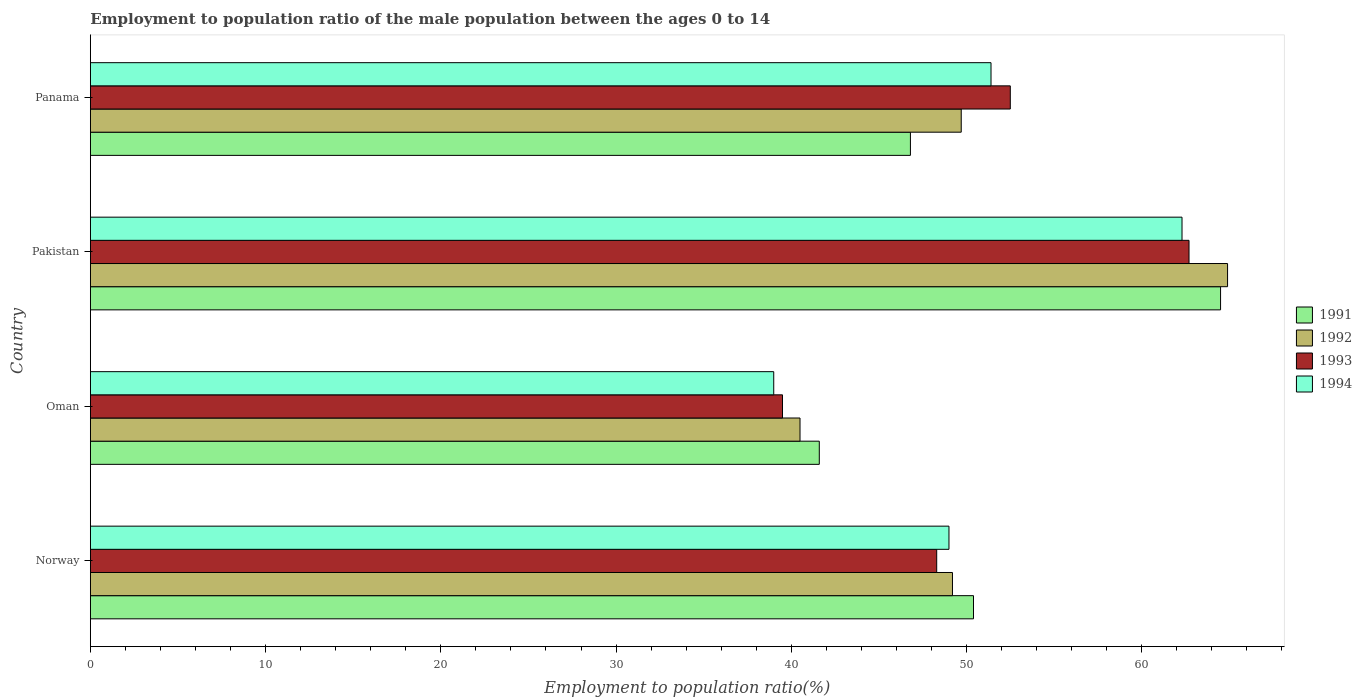How many different coloured bars are there?
Provide a short and direct response. 4. Are the number of bars per tick equal to the number of legend labels?
Provide a succinct answer. Yes. How many bars are there on the 3rd tick from the top?
Offer a terse response. 4. How many bars are there on the 1st tick from the bottom?
Provide a short and direct response. 4. What is the employment to population ratio in 1994 in Panama?
Provide a short and direct response. 51.4. Across all countries, what is the maximum employment to population ratio in 1992?
Your response must be concise. 64.9. Across all countries, what is the minimum employment to population ratio in 1994?
Your answer should be compact. 39. In which country was the employment to population ratio in 1994 minimum?
Ensure brevity in your answer.  Oman. What is the total employment to population ratio in 1991 in the graph?
Provide a short and direct response. 203.3. What is the difference between the employment to population ratio in 1992 in Oman and the employment to population ratio in 1993 in Pakistan?
Keep it short and to the point. -22.2. What is the average employment to population ratio in 1993 per country?
Keep it short and to the point. 50.75. What is the difference between the employment to population ratio in 1991 and employment to population ratio in 1993 in Pakistan?
Provide a short and direct response. 1.8. In how many countries, is the employment to population ratio in 1991 greater than 26 %?
Give a very brief answer. 4. What is the ratio of the employment to population ratio in 1992 in Pakistan to that in Panama?
Your response must be concise. 1.31. Is the employment to population ratio in 1993 in Norway less than that in Panama?
Offer a very short reply. Yes. Is the difference between the employment to population ratio in 1991 in Pakistan and Panama greater than the difference between the employment to population ratio in 1993 in Pakistan and Panama?
Ensure brevity in your answer.  Yes. What is the difference between the highest and the second highest employment to population ratio in 1991?
Provide a succinct answer. 14.1. What is the difference between the highest and the lowest employment to population ratio in 1994?
Ensure brevity in your answer.  23.3. Is it the case that in every country, the sum of the employment to population ratio in 1993 and employment to population ratio in 1991 is greater than the sum of employment to population ratio in 1992 and employment to population ratio in 1994?
Provide a short and direct response. No. What does the 4th bar from the bottom in Panama represents?
Give a very brief answer. 1994. Is it the case that in every country, the sum of the employment to population ratio in 1993 and employment to population ratio in 1992 is greater than the employment to population ratio in 1994?
Ensure brevity in your answer.  Yes. How many countries are there in the graph?
Provide a short and direct response. 4. What is the difference between two consecutive major ticks on the X-axis?
Your answer should be compact. 10. Does the graph contain any zero values?
Your response must be concise. No. Does the graph contain grids?
Ensure brevity in your answer.  No. How many legend labels are there?
Provide a short and direct response. 4. How are the legend labels stacked?
Offer a terse response. Vertical. What is the title of the graph?
Your answer should be very brief. Employment to population ratio of the male population between the ages 0 to 14. Does "1993" appear as one of the legend labels in the graph?
Offer a terse response. Yes. What is the label or title of the Y-axis?
Keep it short and to the point. Country. What is the Employment to population ratio(%) in 1991 in Norway?
Provide a short and direct response. 50.4. What is the Employment to population ratio(%) in 1992 in Norway?
Your response must be concise. 49.2. What is the Employment to population ratio(%) in 1993 in Norway?
Give a very brief answer. 48.3. What is the Employment to population ratio(%) of 1991 in Oman?
Provide a succinct answer. 41.6. What is the Employment to population ratio(%) in 1992 in Oman?
Your answer should be compact. 40.5. What is the Employment to population ratio(%) of 1993 in Oman?
Provide a short and direct response. 39.5. What is the Employment to population ratio(%) of 1994 in Oman?
Ensure brevity in your answer.  39. What is the Employment to population ratio(%) in 1991 in Pakistan?
Offer a very short reply. 64.5. What is the Employment to population ratio(%) of 1992 in Pakistan?
Keep it short and to the point. 64.9. What is the Employment to population ratio(%) in 1993 in Pakistan?
Ensure brevity in your answer.  62.7. What is the Employment to population ratio(%) in 1994 in Pakistan?
Your answer should be very brief. 62.3. What is the Employment to population ratio(%) in 1991 in Panama?
Offer a very short reply. 46.8. What is the Employment to population ratio(%) of 1992 in Panama?
Give a very brief answer. 49.7. What is the Employment to population ratio(%) in 1993 in Panama?
Give a very brief answer. 52.5. What is the Employment to population ratio(%) in 1994 in Panama?
Your response must be concise. 51.4. Across all countries, what is the maximum Employment to population ratio(%) of 1991?
Make the answer very short. 64.5. Across all countries, what is the maximum Employment to population ratio(%) in 1992?
Provide a succinct answer. 64.9. Across all countries, what is the maximum Employment to population ratio(%) in 1993?
Provide a short and direct response. 62.7. Across all countries, what is the maximum Employment to population ratio(%) of 1994?
Provide a succinct answer. 62.3. Across all countries, what is the minimum Employment to population ratio(%) in 1991?
Give a very brief answer. 41.6. Across all countries, what is the minimum Employment to population ratio(%) in 1992?
Keep it short and to the point. 40.5. Across all countries, what is the minimum Employment to population ratio(%) of 1993?
Offer a terse response. 39.5. What is the total Employment to population ratio(%) of 1991 in the graph?
Give a very brief answer. 203.3. What is the total Employment to population ratio(%) in 1992 in the graph?
Offer a very short reply. 204.3. What is the total Employment to population ratio(%) in 1993 in the graph?
Your answer should be compact. 203. What is the total Employment to population ratio(%) of 1994 in the graph?
Make the answer very short. 201.7. What is the difference between the Employment to population ratio(%) in 1991 in Norway and that in Oman?
Your response must be concise. 8.8. What is the difference between the Employment to population ratio(%) in 1992 in Norway and that in Oman?
Provide a succinct answer. 8.7. What is the difference between the Employment to population ratio(%) in 1991 in Norway and that in Pakistan?
Ensure brevity in your answer.  -14.1. What is the difference between the Employment to population ratio(%) of 1992 in Norway and that in Pakistan?
Provide a short and direct response. -15.7. What is the difference between the Employment to population ratio(%) in 1993 in Norway and that in Pakistan?
Keep it short and to the point. -14.4. What is the difference between the Employment to population ratio(%) in 1994 in Norway and that in Pakistan?
Keep it short and to the point. -13.3. What is the difference between the Employment to population ratio(%) of 1991 in Norway and that in Panama?
Offer a very short reply. 3.6. What is the difference between the Employment to population ratio(%) in 1992 in Norway and that in Panama?
Your response must be concise. -0.5. What is the difference between the Employment to population ratio(%) of 1993 in Norway and that in Panama?
Keep it short and to the point. -4.2. What is the difference between the Employment to population ratio(%) in 1991 in Oman and that in Pakistan?
Your answer should be compact. -22.9. What is the difference between the Employment to population ratio(%) of 1992 in Oman and that in Pakistan?
Give a very brief answer. -24.4. What is the difference between the Employment to population ratio(%) in 1993 in Oman and that in Pakistan?
Ensure brevity in your answer.  -23.2. What is the difference between the Employment to population ratio(%) in 1994 in Oman and that in Pakistan?
Keep it short and to the point. -23.3. What is the difference between the Employment to population ratio(%) of 1993 in Oman and that in Panama?
Your response must be concise. -13. What is the difference between the Employment to population ratio(%) of 1994 in Oman and that in Panama?
Your response must be concise. -12.4. What is the difference between the Employment to population ratio(%) in 1991 in Pakistan and that in Panama?
Offer a very short reply. 17.7. What is the difference between the Employment to population ratio(%) of 1992 in Pakistan and that in Panama?
Provide a succinct answer. 15.2. What is the difference between the Employment to population ratio(%) of 1993 in Pakistan and that in Panama?
Give a very brief answer. 10.2. What is the difference between the Employment to population ratio(%) in 1992 in Norway and the Employment to population ratio(%) in 1993 in Oman?
Offer a very short reply. 9.7. What is the difference between the Employment to population ratio(%) in 1993 in Norway and the Employment to population ratio(%) in 1994 in Oman?
Provide a succinct answer. 9.3. What is the difference between the Employment to population ratio(%) in 1991 in Norway and the Employment to population ratio(%) in 1992 in Pakistan?
Provide a short and direct response. -14.5. What is the difference between the Employment to population ratio(%) of 1991 in Norway and the Employment to population ratio(%) of 1993 in Pakistan?
Provide a short and direct response. -12.3. What is the difference between the Employment to population ratio(%) in 1991 in Norway and the Employment to population ratio(%) in 1994 in Pakistan?
Provide a short and direct response. -11.9. What is the difference between the Employment to population ratio(%) of 1993 in Norway and the Employment to population ratio(%) of 1994 in Pakistan?
Your answer should be compact. -14. What is the difference between the Employment to population ratio(%) of 1992 in Norway and the Employment to population ratio(%) of 1994 in Panama?
Offer a terse response. -2.2. What is the difference between the Employment to population ratio(%) in 1993 in Norway and the Employment to population ratio(%) in 1994 in Panama?
Your answer should be very brief. -3.1. What is the difference between the Employment to population ratio(%) in 1991 in Oman and the Employment to population ratio(%) in 1992 in Pakistan?
Your answer should be very brief. -23.3. What is the difference between the Employment to population ratio(%) in 1991 in Oman and the Employment to population ratio(%) in 1993 in Pakistan?
Keep it short and to the point. -21.1. What is the difference between the Employment to population ratio(%) of 1991 in Oman and the Employment to population ratio(%) of 1994 in Pakistan?
Offer a terse response. -20.7. What is the difference between the Employment to population ratio(%) of 1992 in Oman and the Employment to population ratio(%) of 1993 in Pakistan?
Your response must be concise. -22.2. What is the difference between the Employment to population ratio(%) of 1992 in Oman and the Employment to population ratio(%) of 1994 in Pakistan?
Make the answer very short. -21.8. What is the difference between the Employment to population ratio(%) in 1993 in Oman and the Employment to population ratio(%) in 1994 in Pakistan?
Offer a very short reply. -22.8. What is the difference between the Employment to population ratio(%) in 1991 in Oman and the Employment to population ratio(%) in 1993 in Panama?
Your answer should be compact. -10.9. What is the difference between the Employment to population ratio(%) of 1991 in Oman and the Employment to population ratio(%) of 1994 in Panama?
Offer a terse response. -9.8. What is the difference between the Employment to population ratio(%) in 1992 in Oman and the Employment to population ratio(%) in 1994 in Panama?
Ensure brevity in your answer.  -10.9. What is the difference between the Employment to population ratio(%) in 1993 in Pakistan and the Employment to population ratio(%) in 1994 in Panama?
Offer a very short reply. 11.3. What is the average Employment to population ratio(%) of 1991 per country?
Ensure brevity in your answer.  50.83. What is the average Employment to population ratio(%) of 1992 per country?
Make the answer very short. 51.08. What is the average Employment to population ratio(%) in 1993 per country?
Offer a terse response. 50.75. What is the average Employment to population ratio(%) in 1994 per country?
Give a very brief answer. 50.42. What is the difference between the Employment to population ratio(%) in 1992 and Employment to population ratio(%) in 1993 in Norway?
Keep it short and to the point. 0.9. What is the difference between the Employment to population ratio(%) of 1992 and Employment to population ratio(%) of 1994 in Norway?
Your response must be concise. 0.2. What is the difference between the Employment to population ratio(%) in 1993 and Employment to population ratio(%) in 1994 in Norway?
Make the answer very short. -0.7. What is the difference between the Employment to population ratio(%) in 1991 and Employment to population ratio(%) in 1992 in Oman?
Ensure brevity in your answer.  1.1. What is the difference between the Employment to population ratio(%) of 1991 and Employment to population ratio(%) of 1993 in Oman?
Offer a very short reply. 2.1. What is the difference between the Employment to population ratio(%) of 1991 and Employment to population ratio(%) of 1994 in Oman?
Offer a terse response. 2.6. What is the difference between the Employment to population ratio(%) in 1991 and Employment to population ratio(%) in 1993 in Pakistan?
Offer a very short reply. 1.8. What is the difference between the Employment to population ratio(%) in 1992 and Employment to population ratio(%) in 1993 in Pakistan?
Provide a short and direct response. 2.2. What is the difference between the Employment to population ratio(%) of 1991 and Employment to population ratio(%) of 1992 in Panama?
Keep it short and to the point. -2.9. What is the difference between the Employment to population ratio(%) in 1991 and Employment to population ratio(%) in 1993 in Panama?
Provide a short and direct response. -5.7. What is the difference between the Employment to population ratio(%) of 1993 and Employment to population ratio(%) of 1994 in Panama?
Give a very brief answer. 1.1. What is the ratio of the Employment to population ratio(%) of 1991 in Norway to that in Oman?
Keep it short and to the point. 1.21. What is the ratio of the Employment to population ratio(%) in 1992 in Norway to that in Oman?
Keep it short and to the point. 1.21. What is the ratio of the Employment to population ratio(%) in 1993 in Norway to that in Oman?
Your response must be concise. 1.22. What is the ratio of the Employment to population ratio(%) in 1994 in Norway to that in Oman?
Keep it short and to the point. 1.26. What is the ratio of the Employment to population ratio(%) in 1991 in Norway to that in Pakistan?
Provide a short and direct response. 0.78. What is the ratio of the Employment to population ratio(%) in 1992 in Norway to that in Pakistan?
Your answer should be compact. 0.76. What is the ratio of the Employment to population ratio(%) in 1993 in Norway to that in Pakistan?
Keep it short and to the point. 0.77. What is the ratio of the Employment to population ratio(%) of 1994 in Norway to that in Pakistan?
Make the answer very short. 0.79. What is the ratio of the Employment to population ratio(%) of 1994 in Norway to that in Panama?
Your response must be concise. 0.95. What is the ratio of the Employment to population ratio(%) in 1991 in Oman to that in Pakistan?
Offer a terse response. 0.65. What is the ratio of the Employment to population ratio(%) of 1992 in Oman to that in Pakistan?
Make the answer very short. 0.62. What is the ratio of the Employment to population ratio(%) of 1993 in Oman to that in Pakistan?
Ensure brevity in your answer.  0.63. What is the ratio of the Employment to population ratio(%) of 1994 in Oman to that in Pakistan?
Keep it short and to the point. 0.63. What is the ratio of the Employment to population ratio(%) in 1991 in Oman to that in Panama?
Provide a succinct answer. 0.89. What is the ratio of the Employment to population ratio(%) in 1992 in Oman to that in Panama?
Offer a very short reply. 0.81. What is the ratio of the Employment to population ratio(%) of 1993 in Oman to that in Panama?
Give a very brief answer. 0.75. What is the ratio of the Employment to population ratio(%) of 1994 in Oman to that in Panama?
Make the answer very short. 0.76. What is the ratio of the Employment to population ratio(%) in 1991 in Pakistan to that in Panama?
Your response must be concise. 1.38. What is the ratio of the Employment to population ratio(%) of 1992 in Pakistan to that in Panama?
Provide a succinct answer. 1.31. What is the ratio of the Employment to population ratio(%) in 1993 in Pakistan to that in Panama?
Your response must be concise. 1.19. What is the ratio of the Employment to population ratio(%) of 1994 in Pakistan to that in Panama?
Ensure brevity in your answer.  1.21. What is the difference between the highest and the second highest Employment to population ratio(%) of 1993?
Provide a short and direct response. 10.2. What is the difference between the highest and the lowest Employment to population ratio(%) of 1991?
Offer a terse response. 22.9. What is the difference between the highest and the lowest Employment to population ratio(%) in 1992?
Give a very brief answer. 24.4. What is the difference between the highest and the lowest Employment to population ratio(%) of 1993?
Your response must be concise. 23.2. What is the difference between the highest and the lowest Employment to population ratio(%) of 1994?
Ensure brevity in your answer.  23.3. 